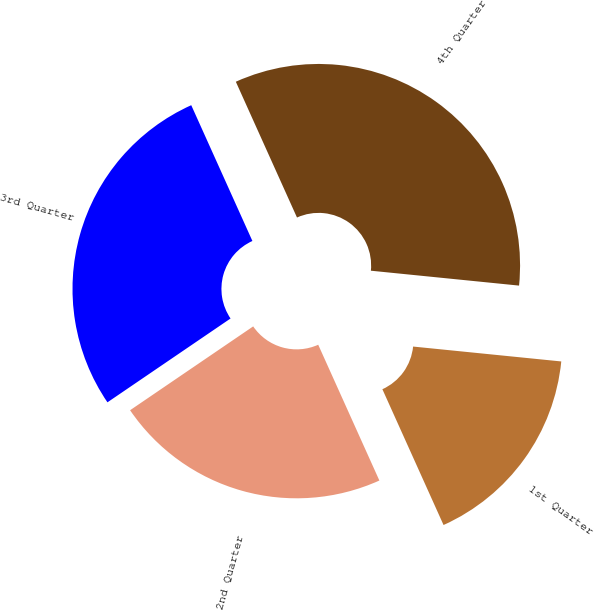<chart> <loc_0><loc_0><loc_500><loc_500><pie_chart><fcel>1st Quarter<fcel>2nd Quarter<fcel>3rd Quarter<fcel>4th Quarter<nl><fcel>16.67%<fcel>22.22%<fcel>27.78%<fcel>33.33%<nl></chart> 